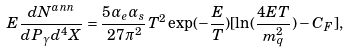Convert formula to latex. <formula><loc_0><loc_0><loc_500><loc_500>E \frac { d N ^ { a n n } } { d P _ { \gamma } d ^ { 4 } X } = \frac { 5 \alpha _ { e } \alpha _ { s } } { 2 7 \pi ^ { 2 } } T ^ { 2 } \exp ( - \frac { E } { T } ) [ \ln ( \frac { 4 E T } { m _ { q } ^ { 2 } } ) - C _ { F } ] ,</formula> 